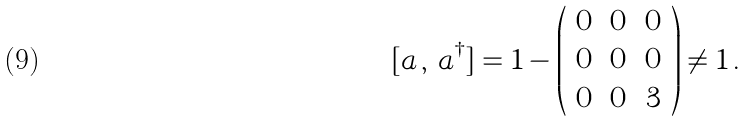<formula> <loc_0><loc_0><loc_500><loc_500>[ a \, , \, a ^ { \dagger } ] = { 1 } - \left ( \begin{array} { c c c } 0 & 0 & 0 \\ 0 & 0 & 0 \\ 0 & 0 & 3 \end{array} \right ) \neq { 1 } \, .</formula> 